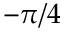Convert formula to latex. <formula><loc_0><loc_0><loc_500><loc_500>- \pi / 4</formula> 